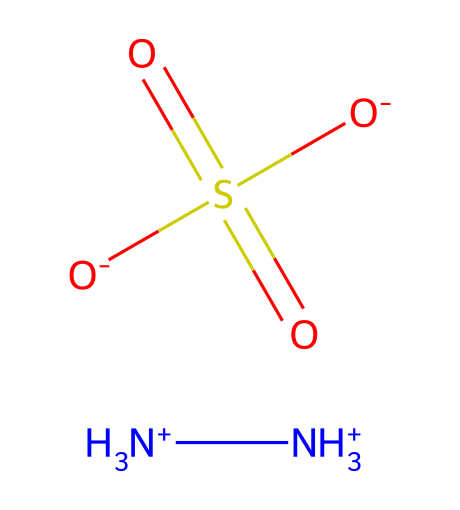What is the total number of nitrogen atoms in hydrazine sulfate? The SMILES representation shows two nitrogen atoms represented by "[NH3+]" at the beginning of the structure. Hence, there are two nitrogen atoms in total.
Answer: 2 How many sulfur atoms are present in this compound? The sulfur atom is indicated by "S(=O)(=O)" in the chemical structure, which confirms just one sulfur atom is present.
Answer: 1 What type of ions are present in hydrazine sulfate? The structure includes ammonium ions indicated by "[NH3+]" and sulfate ions represented by "S(=O)(=O)[O-]". Therefore, both ammonium and sulfate ions are present.
Answer: ammonium and sulfate What is the total number of oxygen atoms in hydrazine sulfate? In the sulfate part of the structure "S(=O)(=O)[O-]", there are three oxygen atoms bonded to the sulfur atom. Thus, the total number of oxygen atoms is three.
Answer: 3 How many total atoms are in hydrazine sulfate? To find the total number of atoms, count the contributions: 2 nitrogen, 1 sulfur, and 3 oxygen. This gives a total of 6 atoms when summed (2 from nitrogen + 1 from sulfur + 3 from oxygen).
Answer: 6 What is the charge of the sulfate ion in hydrazine sulfate? The sulfate ion is shown as "[O-]" along with the sulfur and oxygen, indicating that it has a net charge of -2. Therefore, the sulfate ion carries a -2 charge.
Answer: -2 What is the main functional group present in hydrazine sulfate? The compound contains nitrogen-nitrogen bonds which is characteristic of hydrazines. This functional group is what identifies the compound as a hydrazine derivative.
Answer: hydrazine 